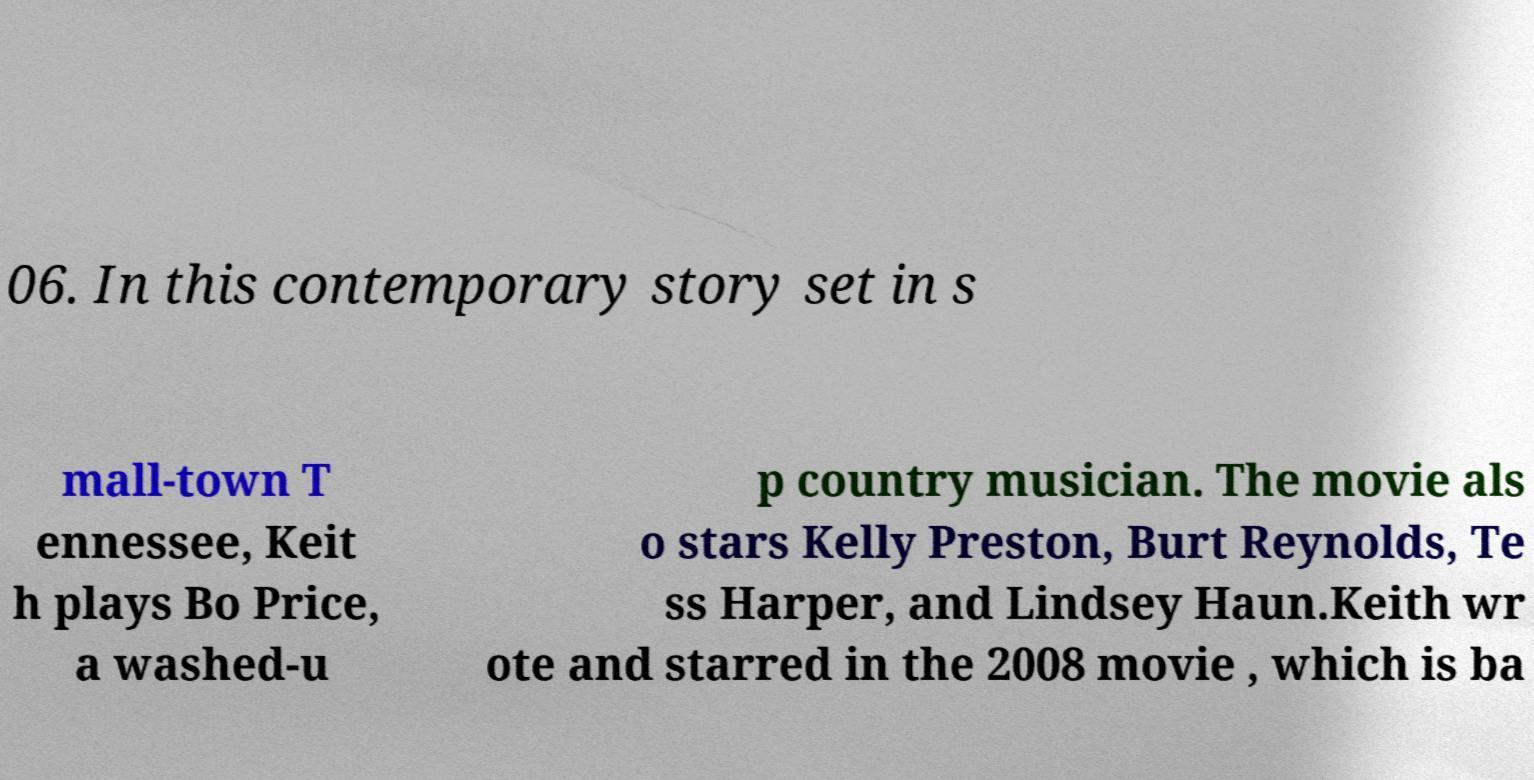Could you extract and type out the text from this image? 06. In this contemporary story set in s mall-town T ennessee, Keit h plays Bo Price, a washed-u p country musician. The movie als o stars Kelly Preston, Burt Reynolds, Te ss Harper, and Lindsey Haun.Keith wr ote and starred in the 2008 movie , which is ba 